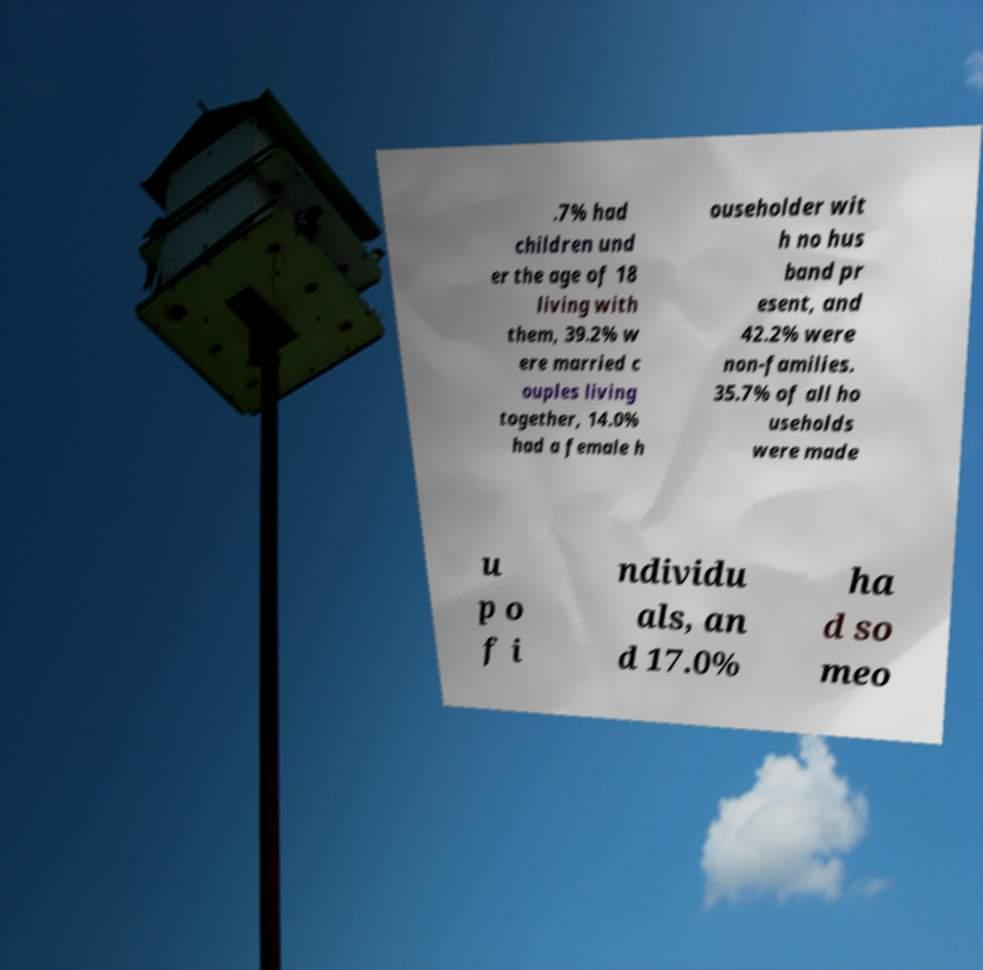For documentation purposes, I need the text within this image transcribed. Could you provide that? .7% had children und er the age of 18 living with them, 39.2% w ere married c ouples living together, 14.0% had a female h ouseholder wit h no hus band pr esent, and 42.2% were non-families. 35.7% of all ho useholds were made u p o f i ndividu als, an d 17.0% ha d so meo 